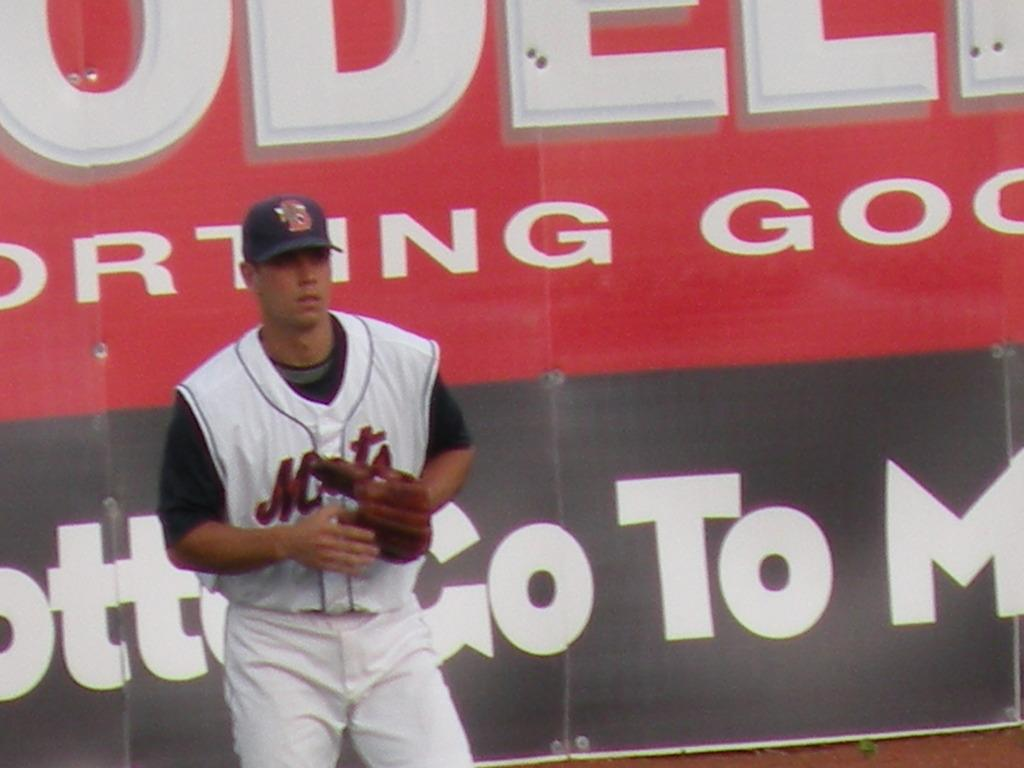<image>
Offer a succinct explanation of the picture presented. A man is wearing a Mets uniform with a glove on. 